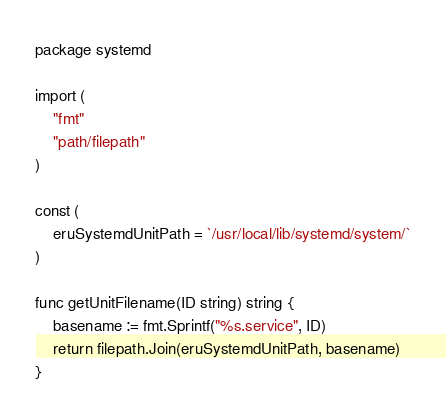Convert code to text. <code><loc_0><loc_0><loc_500><loc_500><_Go_>package systemd

import (
	"fmt"
	"path/filepath"
)

const (
	eruSystemdUnitPath = `/usr/local/lib/systemd/system/`
)

func getUnitFilename(ID string) string {
	basename := fmt.Sprintf("%s.service", ID)
	return filepath.Join(eruSystemdUnitPath, basename)
}
</code> 